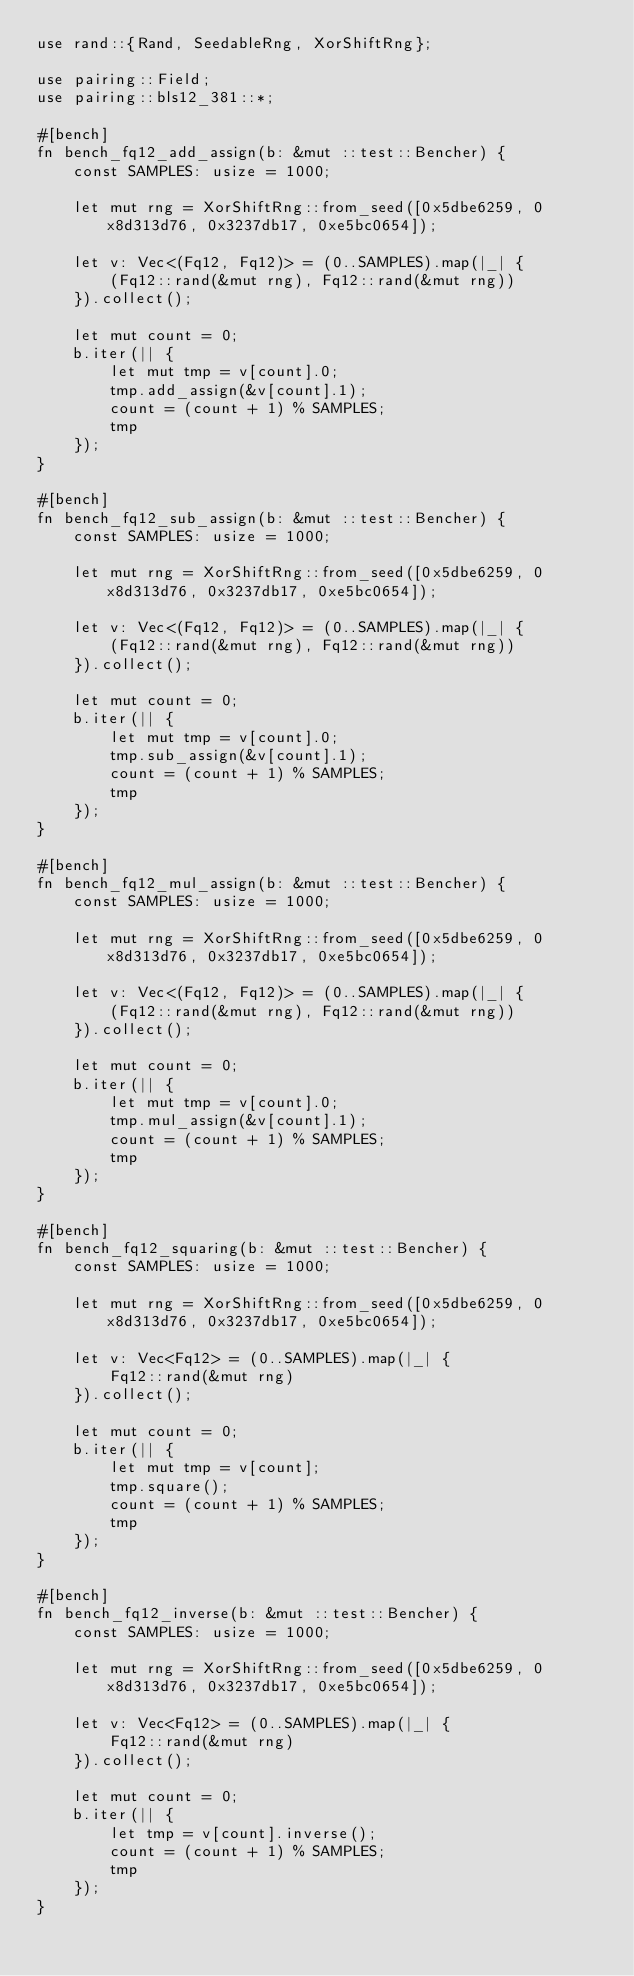<code> <loc_0><loc_0><loc_500><loc_500><_Rust_>use rand::{Rand, SeedableRng, XorShiftRng};

use pairing::Field;
use pairing::bls12_381::*;

#[bench]
fn bench_fq12_add_assign(b: &mut ::test::Bencher) {
    const SAMPLES: usize = 1000;

    let mut rng = XorShiftRng::from_seed([0x5dbe6259, 0x8d313d76, 0x3237db17, 0xe5bc0654]);

    let v: Vec<(Fq12, Fq12)> = (0..SAMPLES).map(|_| {
        (Fq12::rand(&mut rng), Fq12::rand(&mut rng))
    }).collect();

    let mut count = 0;
    b.iter(|| {
        let mut tmp = v[count].0;
        tmp.add_assign(&v[count].1);
        count = (count + 1) % SAMPLES;
        tmp
    });
}

#[bench]
fn bench_fq12_sub_assign(b: &mut ::test::Bencher) {
    const SAMPLES: usize = 1000;

    let mut rng = XorShiftRng::from_seed([0x5dbe6259, 0x8d313d76, 0x3237db17, 0xe5bc0654]);

    let v: Vec<(Fq12, Fq12)> = (0..SAMPLES).map(|_| {
        (Fq12::rand(&mut rng), Fq12::rand(&mut rng))
    }).collect();

    let mut count = 0;
    b.iter(|| {
        let mut tmp = v[count].0;
        tmp.sub_assign(&v[count].1);
        count = (count + 1) % SAMPLES;
        tmp
    });
}

#[bench]
fn bench_fq12_mul_assign(b: &mut ::test::Bencher) {
    const SAMPLES: usize = 1000;

    let mut rng = XorShiftRng::from_seed([0x5dbe6259, 0x8d313d76, 0x3237db17, 0xe5bc0654]);

    let v: Vec<(Fq12, Fq12)> = (0..SAMPLES).map(|_| {
        (Fq12::rand(&mut rng), Fq12::rand(&mut rng))
    }).collect();

    let mut count = 0;
    b.iter(|| {
        let mut tmp = v[count].0;
        tmp.mul_assign(&v[count].1);
        count = (count + 1) % SAMPLES;
        tmp
    });
}

#[bench]
fn bench_fq12_squaring(b: &mut ::test::Bencher) {
    const SAMPLES: usize = 1000;

    let mut rng = XorShiftRng::from_seed([0x5dbe6259, 0x8d313d76, 0x3237db17, 0xe5bc0654]);

    let v: Vec<Fq12> = (0..SAMPLES).map(|_| {
        Fq12::rand(&mut rng)
    }).collect();

    let mut count = 0;
    b.iter(|| {
        let mut tmp = v[count];
        tmp.square();
        count = (count + 1) % SAMPLES;
        tmp
    });
}

#[bench]
fn bench_fq12_inverse(b: &mut ::test::Bencher) {
    const SAMPLES: usize = 1000;

    let mut rng = XorShiftRng::from_seed([0x5dbe6259, 0x8d313d76, 0x3237db17, 0xe5bc0654]);

    let v: Vec<Fq12> = (0..SAMPLES).map(|_| {
        Fq12::rand(&mut rng)
    }).collect();

    let mut count = 0;
    b.iter(|| {
        let tmp = v[count].inverse();
        count = (count + 1) % SAMPLES;
        tmp
    });
}
</code> 